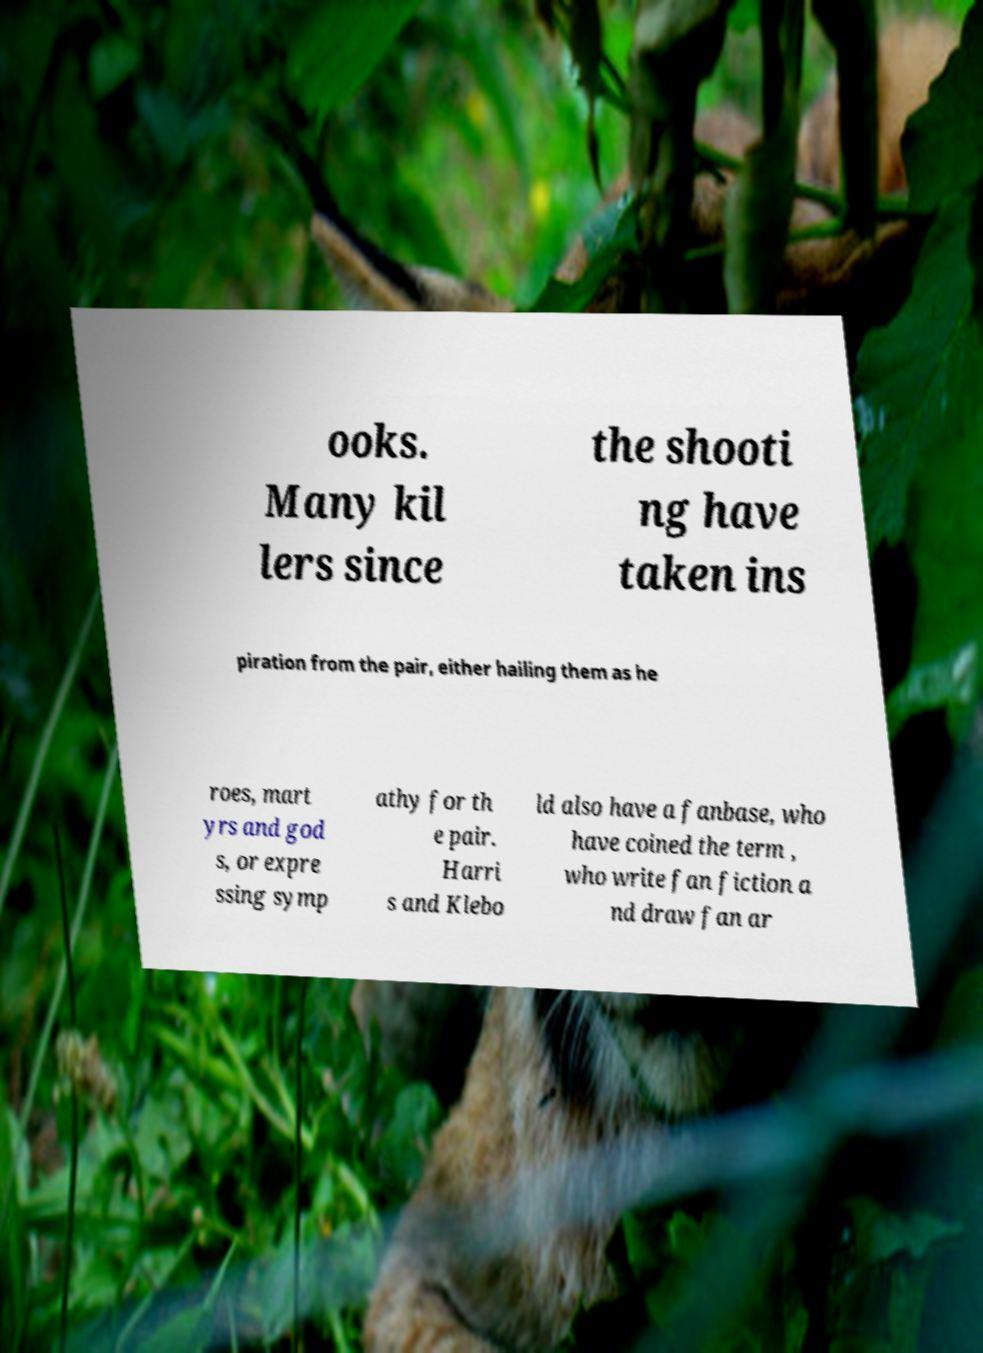There's text embedded in this image that I need extracted. Can you transcribe it verbatim? ooks. Many kil lers since the shooti ng have taken ins piration from the pair, either hailing them as he roes, mart yrs and god s, or expre ssing symp athy for th e pair. Harri s and Klebo ld also have a fanbase, who have coined the term , who write fan fiction a nd draw fan ar 